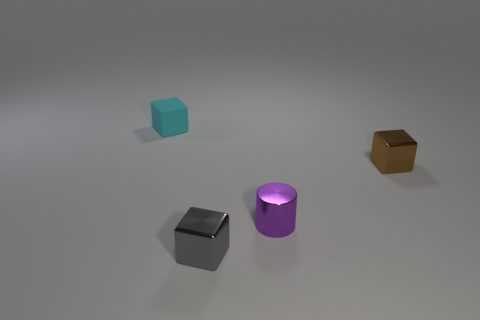The cylinder that is the same size as the matte cube is what color?
Provide a succinct answer. Purple. Is there any other thing that is the same shape as the tiny purple metal object?
Offer a terse response. No. What is the color of the matte thing that is the same shape as the small gray metal thing?
Keep it short and to the point. Cyan. How many things are either tiny gray cubes or tiny things in front of the tiny purple metal cylinder?
Provide a short and direct response. 1. Are there fewer purple metal cylinders in front of the tiny gray shiny block than small cyan cubes?
Your answer should be compact. Yes. There is a object that is behind the small shiny cube to the right of the metallic cube to the left of the brown object; how big is it?
Your answer should be compact. Small. What is the color of the tiny thing that is both to the right of the tiny gray metallic cube and on the left side of the brown metallic cube?
Keep it short and to the point. Purple. What number of big cyan cubes are there?
Your answer should be very brief. 0. Are there any other things that have the same size as the purple shiny thing?
Your answer should be very brief. Yes. Are the tiny cylinder and the gray block made of the same material?
Your answer should be compact. Yes. 